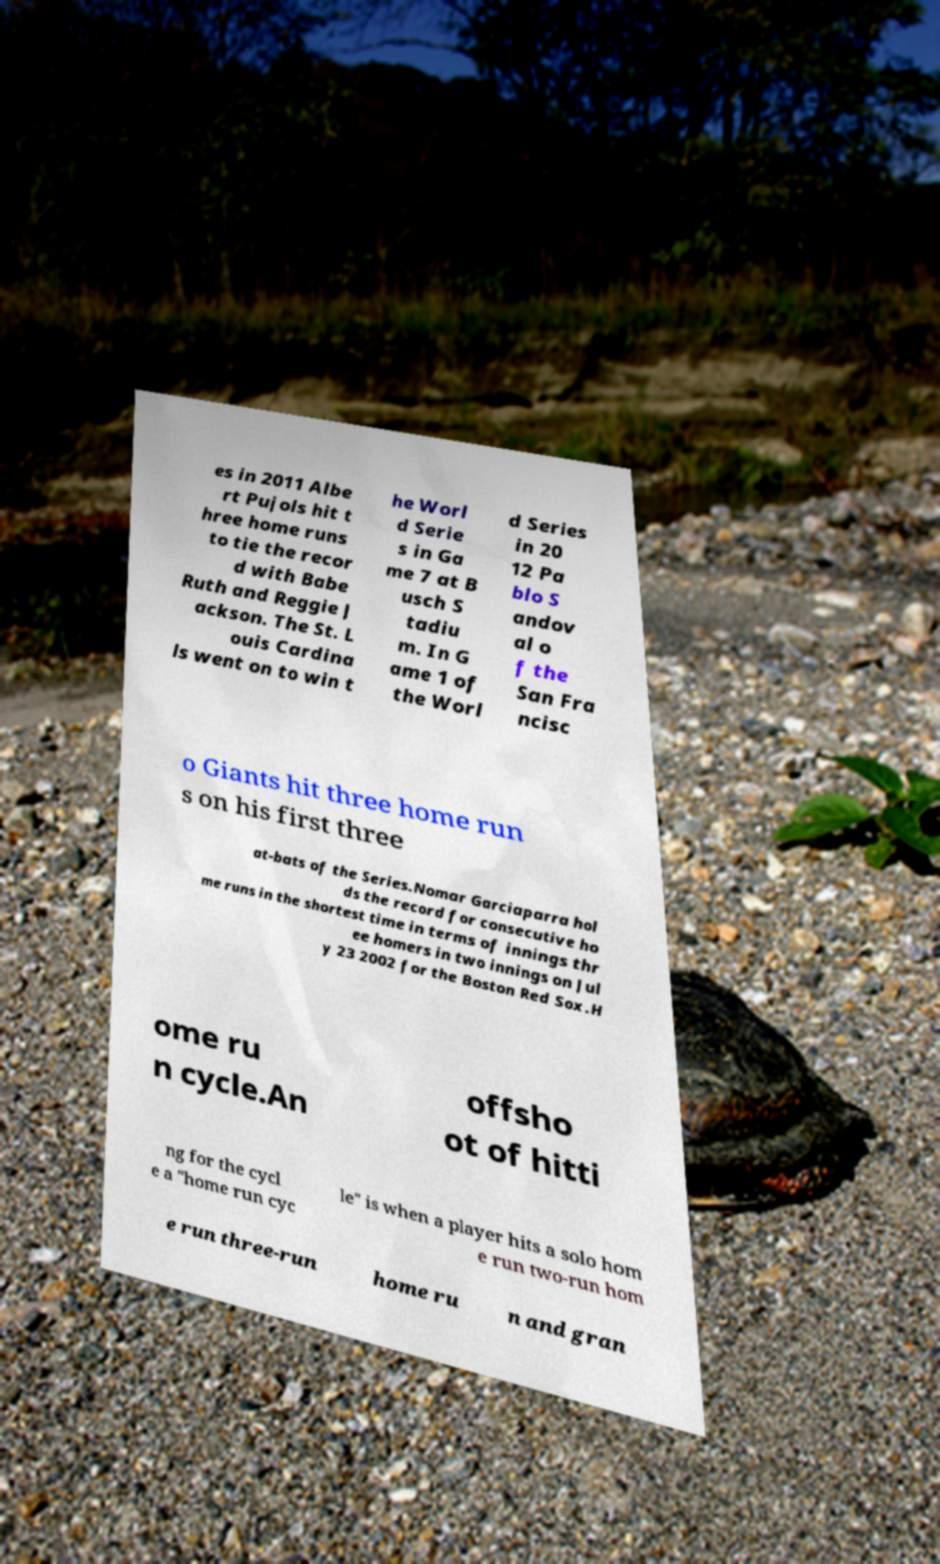Can you accurately transcribe the text from the provided image for me? es in 2011 Albe rt Pujols hit t hree home runs to tie the recor d with Babe Ruth and Reggie J ackson. The St. L ouis Cardina ls went on to win t he Worl d Serie s in Ga me 7 at B usch S tadiu m. In G ame 1 of the Worl d Series in 20 12 Pa blo S andov al o f the San Fra ncisc o Giants hit three home run s on his first three at-bats of the Series.Nomar Garciaparra hol ds the record for consecutive ho me runs in the shortest time in terms of innings thr ee homers in two innings on Jul y 23 2002 for the Boston Red Sox.H ome ru n cycle.An offsho ot of hitti ng for the cycl e a "home run cyc le" is when a player hits a solo hom e run two-run hom e run three-run home ru n and gran 